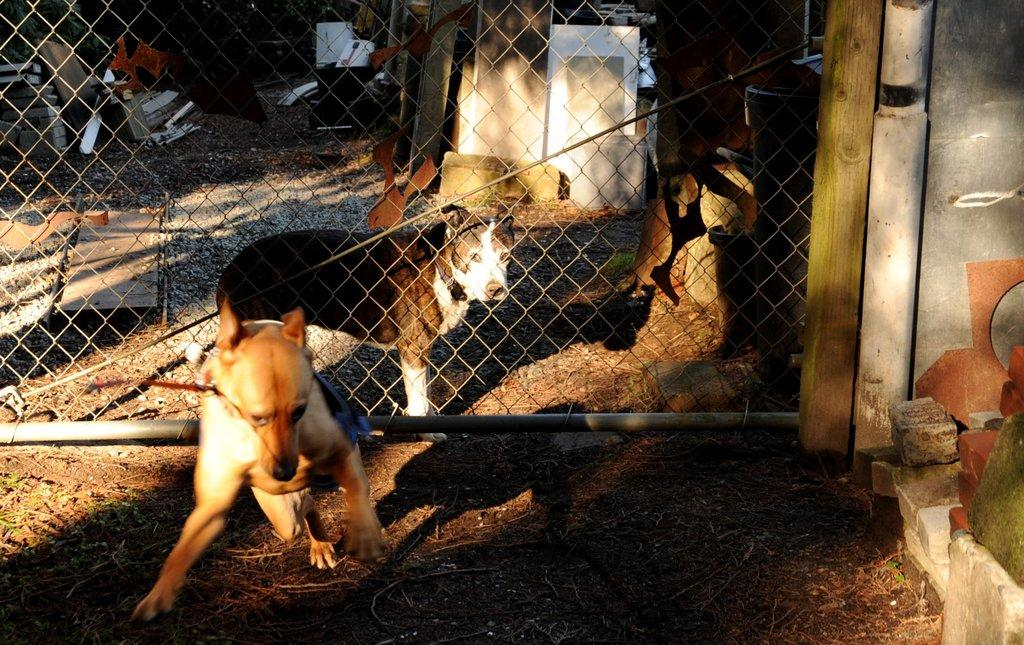What is located at the front of the image? There is an animal in the front of the image. What type of natural elements can be seen in the image? There are stones in the image. What else can be found in the image besides the animal and stones? There are objects in the image. What is in the center of the image? There is a net in the center of the image. What is located behind the net? There are objects and stones behind the net. What type of pies can be seen in the image? There are no pies present in the image. Can you tell me how many brothers are visible in the image? There is no mention of a brother or any people in the image. 